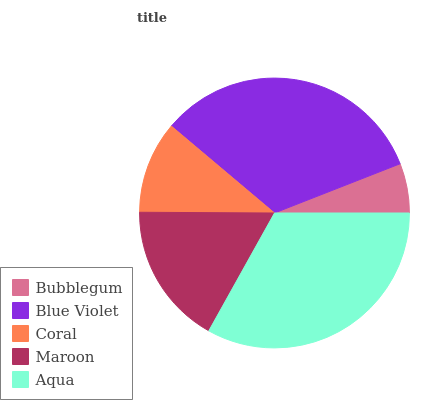Is Bubblegum the minimum?
Answer yes or no. Yes. Is Aqua the maximum?
Answer yes or no. Yes. Is Blue Violet the minimum?
Answer yes or no. No. Is Blue Violet the maximum?
Answer yes or no. No. Is Blue Violet greater than Bubblegum?
Answer yes or no. Yes. Is Bubblegum less than Blue Violet?
Answer yes or no. Yes. Is Bubblegum greater than Blue Violet?
Answer yes or no. No. Is Blue Violet less than Bubblegum?
Answer yes or no. No. Is Maroon the high median?
Answer yes or no. Yes. Is Maroon the low median?
Answer yes or no. Yes. Is Coral the high median?
Answer yes or no. No. Is Bubblegum the low median?
Answer yes or no. No. 